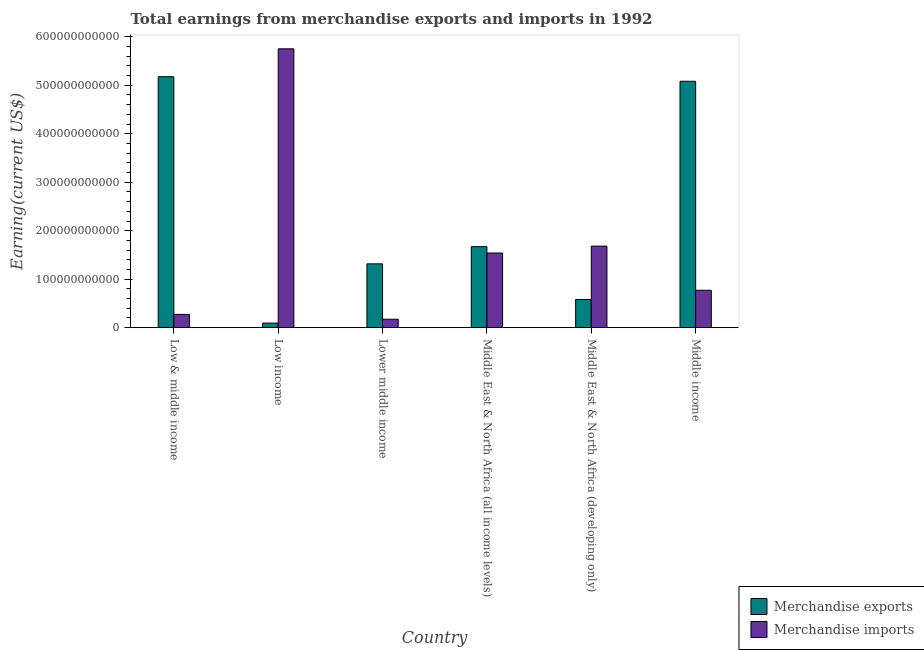How many different coloured bars are there?
Make the answer very short. 2. Are the number of bars per tick equal to the number of legend labels?
Ensure brevity in your answer.  Yes. What is the label of the 6th group of bars from the left?
Your answer should be compact. Middle income. What is the earnings from merchandise exports in Low income?
Offer a very short reply. 9.42e+09. Across all countries, what is the maximum earnings from merchandise imports?
Give a very brief answer. 5.75e+11. Across all countries, what is the minimum earnings from merchandise exports?
Give a very brief answer. 9.42e+09. In which country was the earnings from merchandise exports maximum?
Give a very brief answer. Low & middle income. What is the total earnings from merchandise imports in the graph?
Provide a succinct answer. 1.02e+12. What is the difference between the earnings from merchandise exports in Low & middle income and that in Middle East & North Africa (all income levels)?
Your answer should be compact. 3.51e+11. What is the difference between the earnings from merchandise exports in Lower middle income and the earnings from merchandise imports in Middle East & North Africa (all income levels)?
Give a very brief answer. -2.24e+1. What is the average earnings from merchandise imports per country?
Offer a terse response. 1.70e+11. What is the difference between the earnings from merchandise exports and earnings from merchandise imports in Low & middle income?
Your answer should be very brief. 4.90e+11. What is the ratio of the earnings from merchandise imports in Middle East & North Africa (all income levels) to that in Middle income?
Offer a very short reply. 2. Is the earnings from merchandise imports in Lower middle income less than that in Middle income?
Your answer should be compact. Yes. Is the difference between the earnings from merchandise exports in Low & middle income and Middle East & North Africa (developing only) greater than the difference between the earnings from merchandise imports in Low & middle income and Middle East & North Africa (developing only)?
Provide a succinct answer. Yes. What is the difference between the highest and the second highest earnings from merchandise exports?
Give a very brief answer. 9.42e+09. What is the difference between the highest and the lowest earnings from merchandise exports?
Give a very brief answer. 5.08e+11. How many bars are there?
Give a very brief answer. 12. Are all the bars in the graph horizontal?
Offer a very short reply. No. What is the difference between two consecutive major ticks on the Y-axis?
Provide a succinct answer. 1.00e+11. Are the values on the major ticks of Y-axis written in scientific E-notation?
Offer a very short reply. No. Does the graph contain grids?
Make the answer very short. No. How are the legend labels stacked?
Your answer should be compact. Vertical. What is the title of the graph?
Give a very brief answer. Total earnings from merchandise exports and imports in 1992. Does "Fertility rate" appear as one of the legend labels in the graph?
Keep it short and to the point. No. What is the label or title of the X-axis?
Your answer should be very brief. Country. What is the label or title of the Y-axis?
Offer a terse response. Earning(current US$). What is the Earning(current US$) of Merchandise exports in Low & middle income?
Provide a succinct answer. 5.18e+11. What is the Earning(current US$) of Merchandise imports in Low & middle income?
Your answer should be very brief. 2.74e+1. What is the Earning(current US$) in Merchandise exports in Low income?
Give a very brief answer. 9.42e+09. What is the Earning(current US$) of Merchandise imports in Low income?
Provide a short and direct response. 5.75e+11. What is the Earning(current US$) in Merchandise exports in Lower middle income?
Offer a very short reply. 1.32e+11. What is the Earning(current US$) of Merchandise imports in Lower middle income?
Provide a short and direct response. 1.74e+1. What is the Earning(current US$) in Merchandise exports in Middle East & North Africa (all income levels)?
Provide a short and direct response. 1.67e+11. What is the Earning(current US$) in Merchandise imports in Middle East & North Africa (all income levels)?
Your answer should be compact. 1.54e+11. What is the Earning(current US$) in Merchandise exports in Middle East & North Africa (developing only)?
Provide a succinct answer. 5.81e+1. What is the Earning(current US$) of Merchandise imports in Middle East & North Africa (developing only)?
Your answer should be very brief. 1.68e+11. What is the Earning(current US$) in Merchandise exports in Middle income?
Ensure brevity in your answer.  5.08e+11. What is the Earning(current US$) of Merchandise imports in Middle income?
Your answer should be very brief. 7.71e+1. Across all countries, what is the maximum Earning(current US$) of Merchandise exports?
Provide a succinct answer. 5.18e+11. Across all countries, what is the maximum Earning(current US$) in Merchandise imports?
Provide a succinct answer. 5.75e+11. Across all countries, what is the minimum Earning(current US$) in Merchandise exports?
Make the answer very short. 9.42e+09. Across all countries, what is the minimum Earning(current US$) in Merchandise imports?
Provide a succinct answer. 1.74e+1. What is the total Earning(current US$) in Merchandise exports in the graph?
Offer a very short reply. 1.39e+12. What is the total Earning(current US$) in Merchandise imports in the graph?
Your answer should be very brief. 1.02e+12. What is the difference between the Earning(current US$) in Merchandise exports in Low & middle income and that in Low income?
Your response must be concise. 5.08e+11. What is the difference between the Earning(current US$) in Merchandise imports in Low & middle income and that in Low income?
Make the answer very short. -5.48e+11. What is the difference between the Earning(current US$) in Merchandise exports in Low & middle income and that in Lower middle income?
Your answer should be very brief. 3.86e+11. What is the difference between the Earning(current US$) of Merchandise imports in Low & middle income and that in Lower middle income?
Provide a short and direct response. 9.96e+09. What is the difference between the Earning(current US$) in Merchandise exports in Low & middle income and that in Middle East & North Africa (all income levels)?
Provide a short and direct response. 3.51e+11. What is the difference between the Earning(current US$) in Merchandise imports in Low & middle income and that in Middle East & North Africa (all income levels)?
Offer a terse response. -1.27e+11. What is the difference between the Earning(current US$) of Merchandise exports in Low & middle income and that in Middle East & North Africa (developing only)?
Make the answer very short. 4.60e+11. What is the difference between the Earning(current US$) of Merchandise imports in Low & middle income and that in Middle East & North Africa (developing only)?
Your answer should be compact. -1.41e+11. What is the difference between the Earning(current US$) in Merchandise exports in Low & middle income and that in Middle income?
Ensure brevity in your answer.  9.42e+09. What is the difference between the Earning(current US$) in Merchandise imports in Low & middle income and that in Middle income?
Give a very brief answer. -4.98e+1. What is the difference between the Earning(current US$) in Merchandise exports in Low income and that in Lower middle income?
Keep it short and to the point. -1.22e+11. What is the difference between the Earning(current US$) in Merchandise imports in Low income and that in Lower middle income?
Provide a short and direct response. 5.58e+11. What is the difference between the Earning(current US$) in Merchandise exports in Low income and that in Middle East & North Africa (all income levels)?
Provide a short and direct response. -1.58e+11. What is the difference between the Earning(current US$) in Merchandise imports in Low income and that in Middle East & North Africa (all income levels)?
Offer a very short reply. 4.21e+11. What is the difference between the Earning(current US$) of Merchandise exports in Low income and that in Middle East & North Africa (developing only)?
Provide a short and direct response. -4.87e+1. What is the difference between the Earning(current US$) in Merchandise imports in Low income and that in Middle East & North Africa (developing only)?
Your answer should be compact. 4.07e+11. What is the difference between the Earning(current US$) in Merchandise exports in Low income and that in Middle income?
Keep it short and to the point. -4.99e+11. What is the difference between the Earning(current US$) in Merchandise imports in Low income and that in Middle income?
Provide a succinct answer. 4.98e+11. What is the difference between the Earning(current US$) of Merchandise exports in Lower middle income and that in Middle East & North Africa (all income levels)?
Offer a very short reply. -3.55e+1. What is the difference between the Earning(current US$) of Merchandise imports in Lower middle income and that in Middle East & North Africa (all income levels)?
Ensure brevity in your answer.  -1.37e+11. What is the difference between the Earning(current US$) in Merchandise exports in Lower middle income and that in Middle East & North Africa (developing only)?
Your answer should be very brief. 7.35e+1. What is the difference between the Earning(current US$) of Merchandise imports in Lower middle income and that in Middle East & North Africa (developing only)?
Make the answer very short. -1.51e+11. What is the difference between the Earning(current US$) of Merchandise exports in Lower middle income and that in Middle income?
Provide a short and direct response. -3.77e+11. What is the difference between the Earning(current US$) of Merchandise imports in Lower middle income and that in Middle income?
Give a very brief answer. -5.97e+1. What is the difference between the Earning(current US$) of Merchandise exports in Middle East & North Africa (all income levels) and that in Middle East & North Africa (developing only)?
Your response must be concise. 1.09e+11. What is the difference between the Earning(current US$) in Merchandise imports in Middle East & North Africa (all income levels) and that in Middle East & North Africa (developing only)?
Offer a terse response. -1.42e+1. What is the difference between the Earning(current US$) in Merchandise exports in Middle East & North Africa (all income levels) and that in Middle income?
Make the answer very short. -3.41e+11. What is the difference between the Earning(current US$) of Merchandise imports in Middle East & North Africa (all income levels) and that in Middle income?
Make the answer very short. 7.69e+1. What is the difference between the Earning(current US$) in Merchandise exports in Middle East & North Africa (developing only) and that in Middle income?
Your response must be concise. -4.50e+11. What is the difference between the Earning(current US$) in Merchandise imports in Middle East & North Africa (developing only) and that in Middle income?
Provide a short and direct response. 9.11e+1. What is the difference between the Earning(current US$) in Merchandise exports in Low & middle income and the Earning(current US$) in Merchandise imports in Low income?
Offer a terse response. -5.76e+1. What is the difference between the Earning(current US$) in Merchandise exports in Low & middle income and the Earning(current US$) in Merchandise imports in Lower middle income?
Make the answer very short. 5.00e+11. What is the difference between the Earning(current US$) in Merchandise exports in Low & middle income and the Earning(current US$) in Merchandise imports in Middle East & North Africa (all income levels)?
Your answer should be compact. 3.64e+11. What is the difference between the Earning(current US$) of Merchandise exports in Low & middle income and the Earning(current US$) of Merchandise imports in Middle East & North Africa (developing only)?
Your answer should be compact. 3.49e+11. What is the difference between the Earning(current US$) in Merchandise exports in Low & middle income and the Earning(current US$) in Merchandise imports in Middle income?
Make the answer very short. 4.41e+11. What is the difference between the Earning(current US$) of Merchandise exports in Low income and the Earning(current US$) of Merchandise imports in Lower middle income?
Keep it short and to the point. -7.97e+09. What is the difference between the Earning(current US$) in Merchandise exports in Low income and the Earning(current US$) in Merchandise imports in Middle East & North Africa (all income levels)?
Offer a terse response. -1.45e+11. What is the difference between the Earning(current US$) of Merchandise exports in Low income and the Earning(current US$) of Merchandise imports in Middle East & North Africa (developing only)?
Ensure brevity in your answer.  -1.59e+11. What is the difference between the Earning(current US$) in Merchandise exports in Low income and the Earning(current US$) in Merchandise imports in Middle income?
Keep it short and to the point. -6.77e+1. What is the difference between the Earning(current US$) in Merchandise exports in Lower middle income and the Earning(current US$) in Merchandise imports in Middle East & North Africa (all income levels)?
Make the answer very short. -2.24e+1. What is the difference between the Earning(current US$) of Merchandise exports in Lower middle income and the Earning(current US$) of Merchandise imports in Middle East & North Africa (developing only)?
Provide a succinct answer. -3.66e+1. What is the difference between the Earning(current US$) of Merchandise exports in Lower middle income and the Earning(current US$) of Merchandise imports in Middle income?
Keep it short and to the point. 5.45e+1. What is the difference between the Earning(current US$) of Merchandise exports in Middle East & North Africa (all income levels) and the Earning(current US$) of Merchandise imports in Middle East & North Africa (developing only)?
Offer a terse response. -1.10e+09. What is the difference between the Earning(current US$) of Merchandise exports in Middle East & North Africa (all income levels) and the Earning(current US$) of Merchandise imports in Middle income?
Offer a very short reply. 9.00e+1. What is the difference between the Earning(current US$) of Merchandise exports in Middle East & North Africa (developing only) and the Earning(current US$) of Merchandise imports in Middle income?
Make the answer very short. -1.90e+1. What is the average Earning(current US$) of Merchandise exports per country?
Your answer should be compact. 2.32e+11. What is the average Earning(current US$) in Merchandise imports per country?
Ensure brevity in your answer.  1.70e+11. What is the difference between the Earning(current US$) in Merchandise exports and Earning(current US$) in Merchandise imports in Low & middle income?
Your response must be concise. 4.90e+11. What is the difference between the Earning(current US$) in Merchandise exports and Earning(current US$) in Merchandise imports in Low income?
Offer a terse response. -5.66e+11. What is the difference between the Earning(current US$) of Merchandise exports and Earning(current US$) of Merchandise imports in Lower middle income?
Your answer should be very brief. 1.14e+11. What is the difference between the Earning(current US$) of Merchandise exports and Earning(current US$) of Merchandise imports in Middle East & North Africa (all income levels)?
Offer a very short reply. 1.31e+1. What is the difference between the Earning(current US$) in Merchandise exports and Earning(current US$) in Merchandise imports in Middle East & North Africa (developing only)?
Keep it short and to the point. -1.10e+11. What is the difference between the Earning(current US$) of Merchandise exports and Earning(current US$) of Merchandise imports in Middle income?
Your response must be concise. 4.31e+11. What is the ratio of the Earning(current US$) in Merchandise exports in Low & middle income to that in Low income?
Provide a succinct answer. 54.93. What is the ratio of the Earning(current US$) in Merchandise imports in Low & middle income to that in Low income?
Provide a succinct answer. 0.05. What is the ratio of the Earning(current US$) of Merchandise exports in Low & middle income to that in Lower middle income?
Offer a terse response. 3.93. What is the ratio of the Earning(current US$) in Merchandise imports in Low & middle income to that in Lower middle income?
Your answer should be compact. 1.57. What is the ratio of the Earning(current US$) of Merchandise exports in Low & middle income to that in Middle East & North Africa (all income levels)?
Provide a short and direct response. 3.1. What is the ratio of the Earning(current US$) of Merchandise imports in Low & middle income to that in Middle East & North Africa (all income levels)?
Ensure brevity in your answer.  0.18. What is the ratio of the Earning(current US$) of Merchandise exports in Low & middle income to that in Middle East & North Africa (developing only)?
Your answer should be compact. 8.9. What is the ratio of the Earning(current US$) of Merchandise imports in Low & middle income to that in Middle East & North Africa (developing only)?
Make the answer very short. 0.16. What is the ratio of the Earning(current US$) in Merchandise exports in Low & middle income to that in Middle income?
Your answer should be compact. 1.02. What is the ratio of the Earning(current US$) in Merchandise imports in Low & middle income to that in Middle income?
Offer a very short reply. 0.35. What is the ratio of the Earning(current US$) of Merchandise exports in Low income to that in Lower middle income?
Give a very brief answer. 0.07. What is the ratio of the Earning(current US$) in Merchandise imports in Low income to that in Lower middle income?
Offer a very short reply. 33.07. What is the ratio of the Earning(current US$) in Merchandise exports in Low income to that in Middle East & North Africa (all income levels)?
Provide a short and direct response. 0.06. What is the ratio of the Earning(current US$) of Merchandise imports in Low income to that in Middle East & North Africa (all income levels)?
Your response must be concise. 3.74. What is the ratio of the Earning(current US$) in Merchandise exports in Low income to that in Middle East & North Africa (developing only)?
Ensure brevity in your answer.  0.16. What is the ratio of the Earning(current US$) in Merchandise imports in Low income to that in Middle East & North Africa (developing only)?
Give a very brief answer. 3.42. What is the ratio of the Earning(current US$) of Merchandise exports in Low income to that in Middle income?
Your answer should be compact. 0.02. What is the ratio of the Earning(current US$) of Merchandise imports in Low income to that in Middle income?
Make the answer very short. 7.46. What is the ratio of the Earning(current US$) of Merchandise exports in Lower middle income to that in Middle East & North Africa (all income levels)?
Your response must be concise. 0.79. What is the ratio of the Earning(current US$) in Merchandise imports in Lower middle income to that in Middle East & North Africa (all income levels)?
Ensure brevity in your answer.  0.11. What is the ratio of the Earning(current US$) in Merchandise exports in Lower middle income to that in Middle East & North Africa (developing only)?
Offer a very short reply. 2.26. What is the ratio of the Earning(current US$) of Merchandise imports in Lower middle income to that in Middle East & North Africa (developing only)?
Your answer should be very brief. 0.1. What is the ratio of the Earning(current US$) in Merchandise exports in Lower middle income to that in Middle income?
Keep it short and to the point. 0.26. What is the ratio of the Earning(current US$) in Merchandise imports in Lower middle income to that in Middle income?
Provide a short and direct response. 0.23. What is the ratio of the Earning(current US$) in Merchandise exports in Middle East & North Africa (all income levels) to that in Middle East & North Africa (developing only)?
Offer a very short reply. 2.87. What is the ratio of the Earning(current US$) of Merchandise imports in Middle East & North Africa (all income levels) to that in Middle East & North Africa (developing only)?
Offer a terse response. 0.92. What is the ratio of the Earning(current US$) in Merchandise exports in Middle East & North Africa (all income levels) to that in Middle income?
Keep it short and to the point. 0.33. What is the ratio of the Earning(current US$) in Merchandise imports in Middle East & North Africa (all income levels) to that in Middle income?
Offer a very short reply. 2. What is the ratio of the Earning(current US$) of Merchandise exports in Middle East & North Africa (developing only) to that in Middle income?
Ensure brevity in your answer.  0.11. What is the ratio of the Earning(current US$) of Merchandise imports in Middle East & North Africa (developing only) to that in Middle income?
Offer a very short reply. 2.18. What is the difference between the highest and the second highest Earning(current US$) in Merchandise exports?
Ensure brevity in your answer.  9.42e+09. What is the difference between the highest and the second highest Earning(current US$) in Merchandise imports?
Offer a terse response. 4.07e+11. What is the difference between the highest and the lowest Earning(current US$) in Merchandise exports?
Your response must be concise. 5.08e+11. What is the difference between the highest and the lowest Earning(current US$) in Merchandise imports?
Your answer should be very brief. 5.58e+11. 